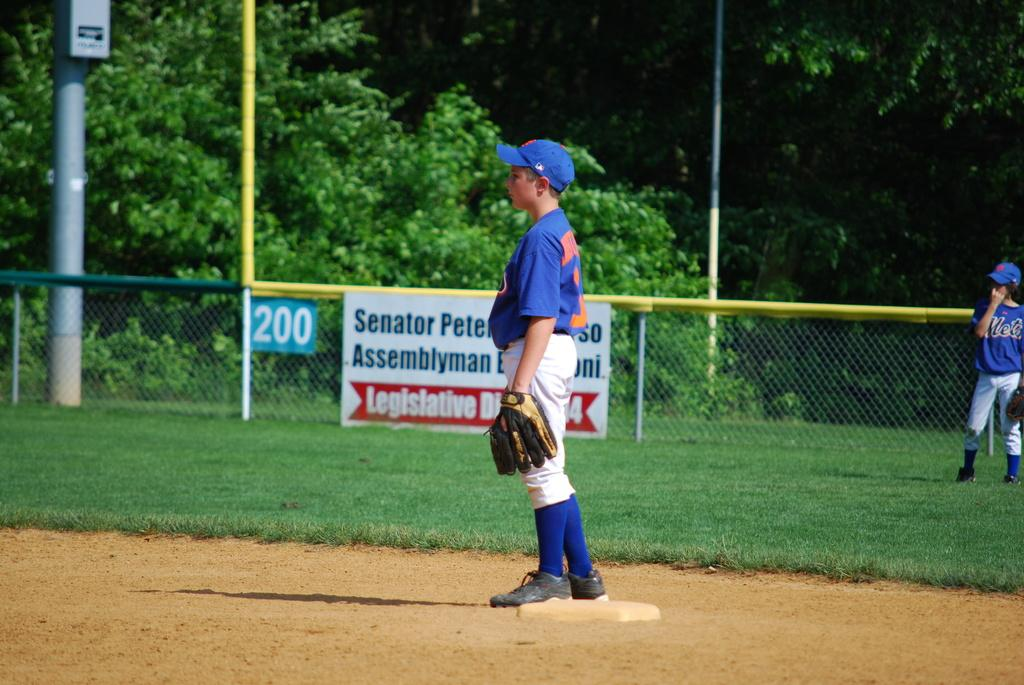Provide a one-sentence caption for the provided image. A kid is standing out in a baseball field in front of a sign saying 200. 